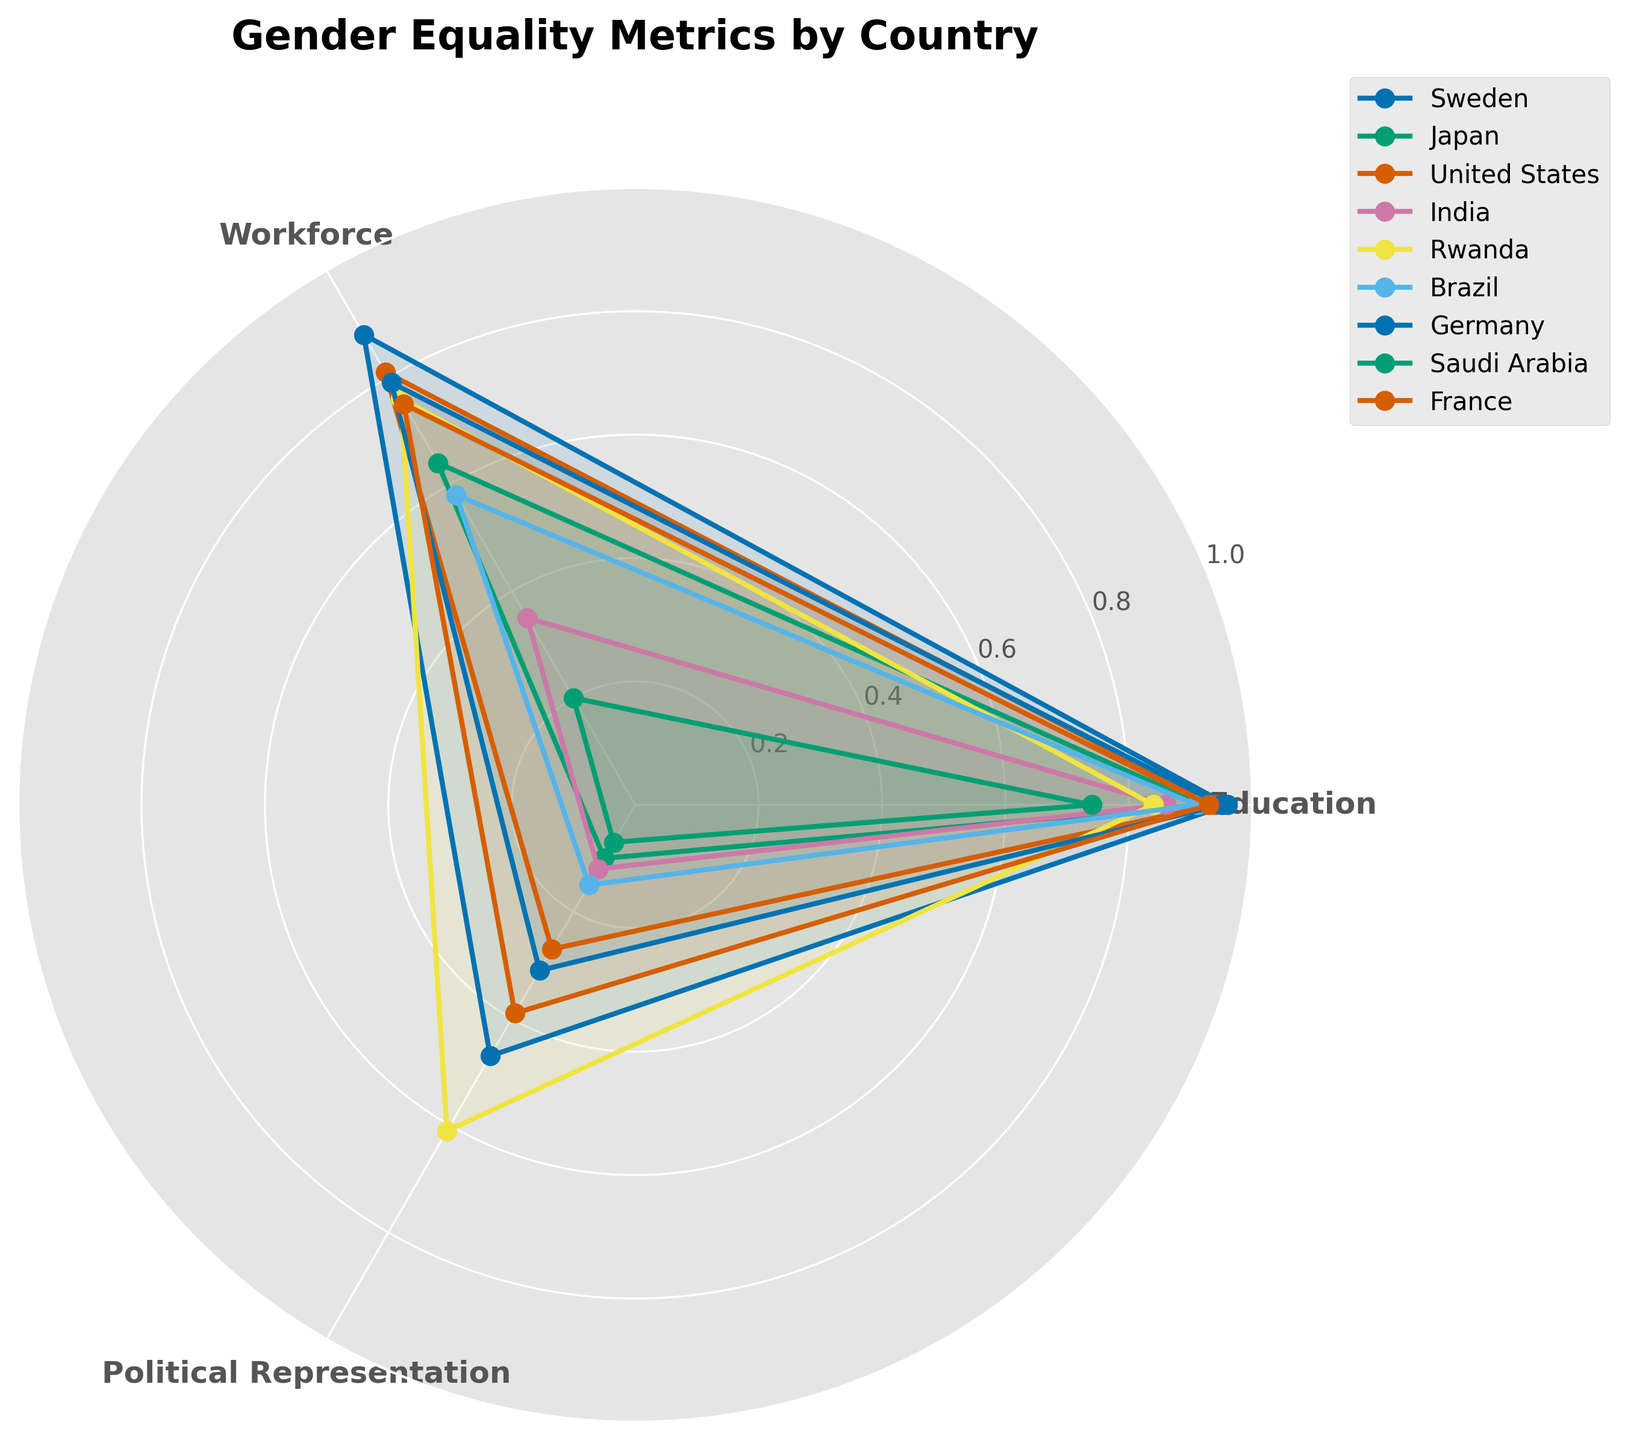What is the title of the radar chart? The title of the radar chart is usually placed at the top and provides a summary of the content of the chart. Reading the text at the top, we find that the title is "Gender Equality Metrics by Country".
Answer: Gender Equality Metrics by Country Which country has the highest score for education? To determine which country has the highest score for education, observe the outermost points on the 'Education' axis. Sweden has the highest score with a value of 0.96.
Answer: Sweden What is the average score of political representation across all countries? Sum all the countries' political representation scores and divide by the number of countries. (0.47 + 0.10 + 0.27 + 0.12 + 0.61 + 0.15 + 0.31 + 0.07 + 0.39) / 9 = 2.49 / 9.
Answer: 0.28 How does Japan compare to the United States in terms of workforce gender equality? Look at the values on the 'Workforce' axis for both Japan and the United States. Japan has a score of 0.64, while the United States has a score of 0.81. Comparing the two, the United States has a higher score than Japan.
Answer: The United States is better Which countries have a political representation score greater than 0.30? Identify the countries with scores on the 'Political Representation' axis that are above 0.30. They are Sweden (0.47), Rwanda (0.61), Germany (0.31), and France (0.39).
Answer: Sweden, Rwanda, Germany, France What is the difference between the highest and lowest scores for workforce gender equality among the countries? First, find the highest and lowest workforce scores from the chart: Highest is Sweden (0.88) and lowest is Saudi Arabia (0.20). The difference is 0.88 - 0.20.
Answer: 0.68 Which country has the most balanced scores across all metrics? To find the country with the most balanced scores, observe for the country whose radar plot forms the most symmetric and approximately equal distances from the center. Rwanda, with scores close to each other (0.84, 0.76, 0.61), appears to be most balanced.
Answer: Rwanda Between Germany and France, which country has a better overall gender equality score (considering all three metrics)? Sum the scores for Education, Workforce, and Political Representation for both countries and compare: Germany (0.95 + 0.79 + 0.31 = 2.05) and France (0.93 + 0.75 + 0.39 = 2.07). France has a marginally higher total score.
Answer: France Which country has the lowest combined score for all metrics? Sum the scores for Education, Workforce, and Political Representation for each country and find the lowest: Saudi Arabia (0.74 + 0.20 + 0.07 = 1.01), which is the lowest combined score.
Answer: Saudi Arabia 